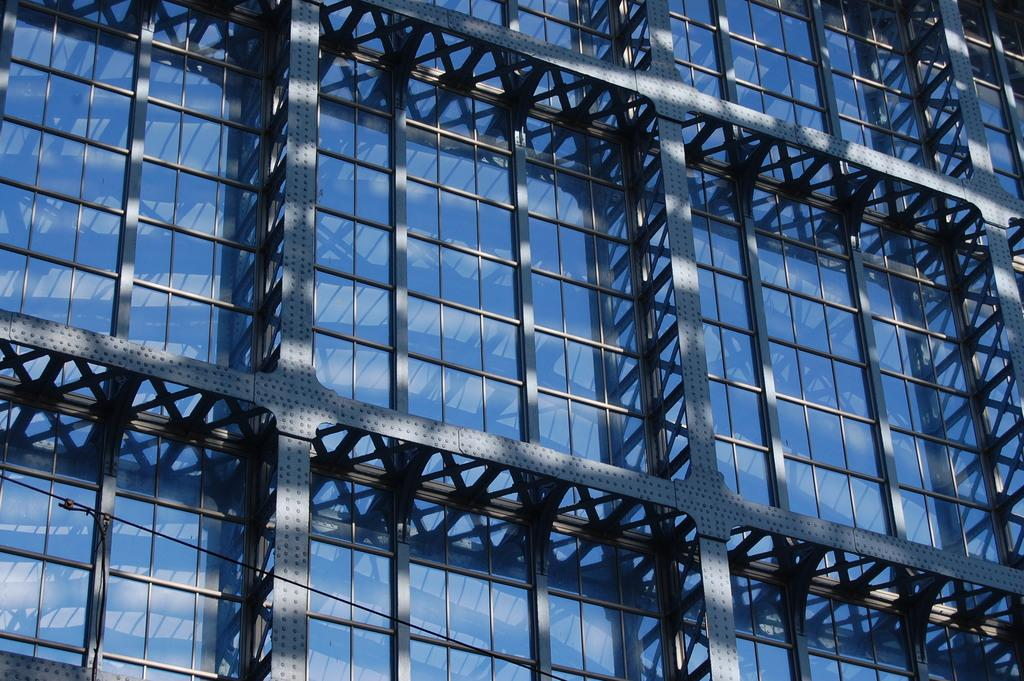What type of structure is present in the image? There is a building in the image. What material can be seen in the image? Metal rods are visible in the image. What type of volleyball game is being played in the image? There is no volleyball game present in the image. What fictional company is responsible for the construction of the building in the image? The image does not provide information about the company responsible for the construction of the building. 